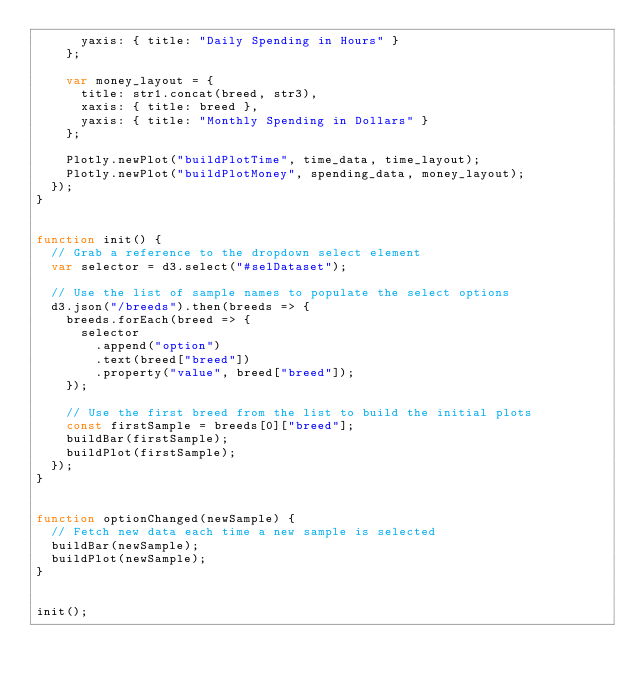<code> <loc_0><loc_0><loc_500><loc_500><_JavaScript_>      yaxis: { title: "Daily Spending in Hours" }
    };

    var money_layout = {
      title: str1.concat(breed, str3),
      xaxis: { title: breed },
      yaxis: { title: "Monthly Spending in Dollars" }
    };

    Plotly.newPlot("buildPlotTime", time_data, time_layout);
    Plotly.newPlot("buildPlotMoney", spending_data, money_layout);
  });
}


function init() {
  // Grab a reference to the dropdown select element
  var selector = d3.select("#selDataset");

  // Use the list of sample names to populate the select options
  d3.json("/breeds").then(breeds => {
    breeds.forEach(breed => {
      selector
        .append("option")
        .text(breed["breed"])
        .property("value", breed["breed"]);
    });

    // Use the first breed from the list to build the initial plots
    const firstSample = breeds[0]["breed"];
    buildBar(firstSample);
    buildPlot(firstSample);
  });
}


function optionChanged(newSample) {
  // Fetch new data each time a new sample is selected
  buildBar(newSample);
  buildPlot(newSample);
}


init();
</code> 